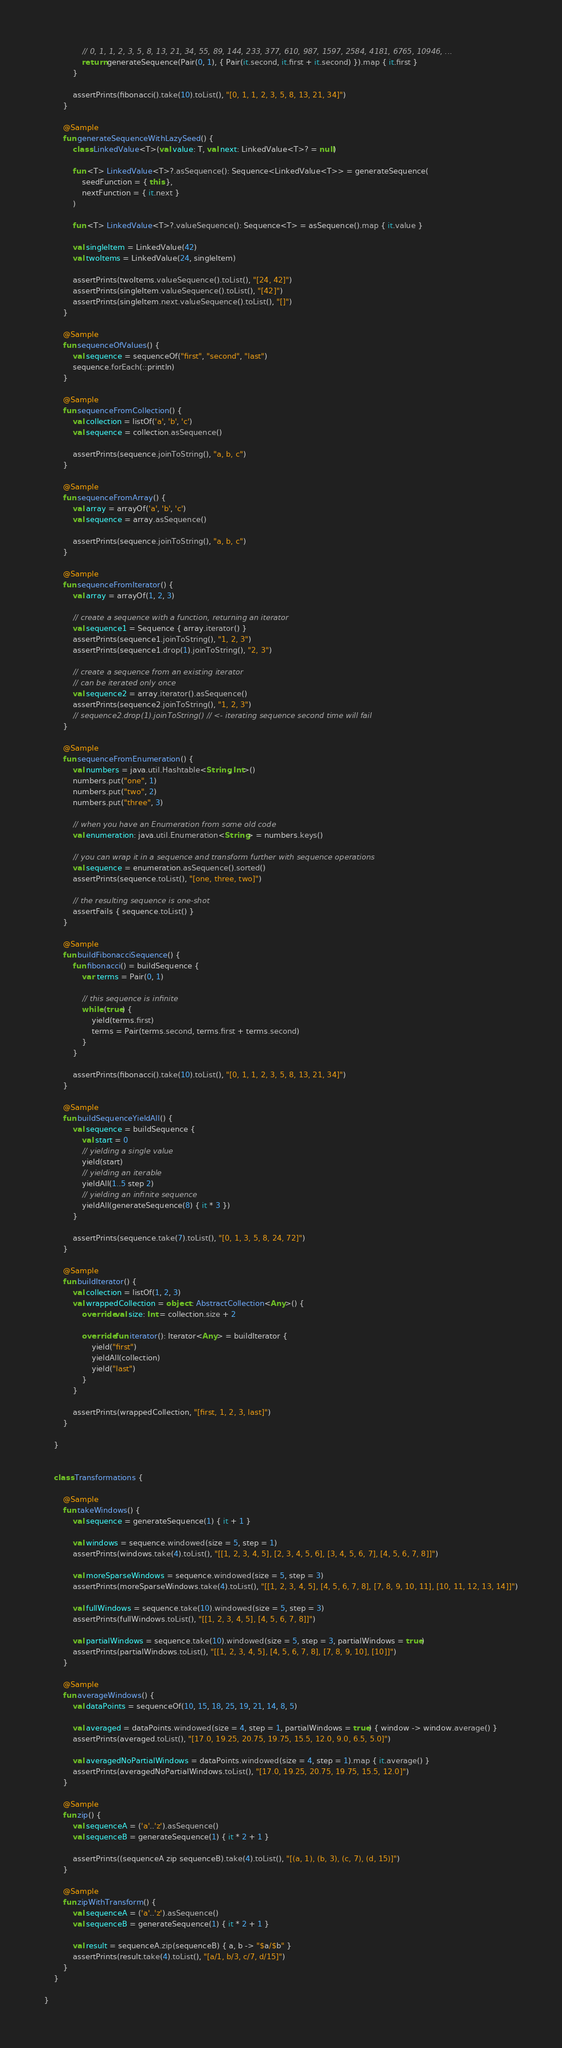<code> <loc_0><loc_0><loc_500><loc_500><_Kotlin_>                // 0, 1, 1, 2, 3, 5, 8, 13, 21, 34, 55, 89, 144, 233, 377, 610, 987, 1597, 2584, 4181, 6765, 10946, ...
                return generateSequence(Pair(0, 1), { Pair(it.second, it.first + it.second) }).map { it.first }
            }

            assertPrints(fibonacci().take(10).toList(), "[0, 1, 1, 2, 3, 5, 8, 13, 21, 34]")
        }

        @Sample
        fun generateSequenceWithLazySeed() {
            class LinkedValue<T>(val value: T, val next: LinkedValue<T>? = null)

            fun <T> LinkedValue<T>?.asSequence(): Sequence<LinkedValue<T>> = generateSequence(
                seedFunction = { this },
                nextFunction = { it.next }
            )

            fun <T> LinkedValue<T>?.valueSequence(): Sequence<T> = asSequence().map { it.value }

            val singleItem = LinkedValue(42)
            val twoItems = LinkedValue(24, singleItem)

            assertPrints(twoItems.valueSequence().toList(), "[24, 42]")
            assertPrints(singleItem.valueSequence().toList(), "[42]")
            assertPrints(singleItem.next.valueSequence().toList(), "[]")
        }

        @Sample
        fun sequenceOfValues() {
            val sequence = sequenceOf("first", "second", "last")
            sequence.forEach(::println)
        }

        @Sample
        fun sequenceFromCollection() {
            val collection = listOf('a', 'b', 'c')
            val sequence = collection.asSequence()

            assertPrints(sequence.joinToString(), "a, b, c")
        }

        @Sample
        fun sequenceFromArray() {
            val array = arrayOf('a', 'b', 'c')
            val sequence = array.asSequence()

            assertPrints(sequence.joinToString(), "a, b, c")
        }

        @Sample
        fun sequenceFromIterator() {
            val array = arrayOf(1, 2, 3)

            // create a sequence with a function, returning an iterator
            val sequence1 = Sequence { array.iterator() }
            assertPrints(sequence1.joinToString(), "1, 2, 3")
            assertPrints(sequence1.drop(1).joinToString(), "2, 3")

            // create a sequence from an existing iterator
            // can be iterated only once
            val sequence2 = array.iterator().asSequence()
            assertPrints(sequence2.joinToString(), "1, 2, 3")
            // sequence2.drop(1).joinToString() // <- iterating sequence second time will fail
        }

        @Sample
        fun sequenceFromEnumeration() {
            val numbers = java.util.Hashtable<String, Int>()
            numbers.put("one", 1)
            numbers.put("two", 2)
            numbers.put("three", 3)

            // when you have an Enumeration from some old code
            val enumeration: java.util.Enumeration<String> = numbers.keys()

            // you can wrap it in a sequence and transform further with sequence operations
            val sequence = enumeration.asSequence().sorted()
            assertPrints(sequence.toList(), "[one, three, two]")

            // the resulting sequence is one-shot
            assertFails { sequence.toList() }
        }

        @Sample
        fun buildFibonacciSequence() {
            fun fibonacci() = buildSequence {
                var terms = Pair(0, 1)

                // this sequence is infinite
                while (true) {
                    yield(terms.first)
                    terms = Pair(terms.second, terms.first + terms.second)
                }
            }

            assertPrints(fibonacci().take(10).toList(), "[0, 1, 1, 2, 3, 5, 8, 13, 21, 34]")
        }

        @Sample
        fun buildSequenceYieldAll() {
            val sequence = buildSequence {
                val start = 0
                // yielding a single value
                yield(start)
                // yielding an iterable
                yieldAll(1..5 step 2)
                // yielding an infinite sequence
                yieldAll(generateSequence(8) { it * 3 })
            }

            assertPrints(sequence.take(7).toList(), "[0, 1, 3, 5, 8, 24, 72]")
        }

        @Sample
        fun buildIterator() {
            val collection = listOf(1, 2, 3)
            val wrappedCollection = object : AbstractCollection<Any>() {
                override val size: Int = collection.size + 2

                override fun iterator(): Iterator<Any> = buildIterator {
                    yield("first")
                    yieldAll(collection)
                    yield("last")
                }
            }

            assertPrints(wrappedCollection, "[first, 1, 2, 3, last]")
        }

    }


    class Transformations {

        @Sample
        fun takeWindows() {
            val sequence = generateSequence(1) { it + 1 }

            val windows = sequence.windowed(size = 5, step = 1)
            assertPrints(windows.take(4).toList(), "[[1, 2, 3, 4, 5], [2, 3, 4, 5, 6], [3, 4, 5, 6, 7], [4, 5, 6, 7, 8]]")

            val moreSparseWindows = sequence.windowed(size = 5, step = 3)
            assertPrints(moreSparseWindows.take(4).toList(), "[[1, 2, 3, 4, 5], [4, 5, 6, 7, 8], [7, 8, 9, 10, 11], [10, 11, 12, 13, 14]]")

            val fullWindows = sequence.take(10).windowed(size = 5, step = 3)
            assertPrints(fullWindows.toList(), "[[1, 2, 3, 4, 5], [4, 5, 6, 7, 8]]")

            val partialWindows = sequence.take(10).windowed(size = 5, step = 3, partialWindows = true)
            assertPrints(partialWindows.toList(), "[[1, 2, 3, 4, 5], [4, 5, 6, 7, 8], [7, 8, 9, 10], [10]]")
        }

        @Sample
        fun averageWindows() {
            val dataPoints = sequenceOf(10, 15, 18, 25, 19, 21, 14, 8, 5)

            val averaged = dataPoints.windowed(size = 4, step = 1, partialWindows = true) { window -> window.average() }
            assertPrints(averaged.toList(), "[17.0, 19.25, 20.75, 19.75, 15.5, 12.0, 9.0, 6.5, 5.0]")

            val averagedNoPartialWindows = dataPoints.windowed(size = 4, step = 1).map { it.average() }
            assertPrints(averagedNoPartialWindows.toList(), "[17.0, 19.25, 20.75, 19.75, 15.5, 12.0]")
        }

        @Sample
        fun zip() {
            val sequenceA = ('a'..'z').asSequence()
            val sequenceB = generateSequence(1) { it * 2 + 1 }

            assertPrints((sequenceA zip sequenceB).take(4).toList(), "[(a, 1), (b, 3), (c, 7), (d, 15)]")
        }

        @Sample
        fun zipWithTransform() {
            val sequenceA = ('a'..'z').asSequence()
            val sequenceB = generateSequence(1) { it * 2 + 1 }

            val result = sequenceA.zip(sequenceB) { a, b -> "$a/$b" }
            assertPrints(result.take(4).toList(), "[a/1, b/3, c/7, d/15]")
        }
    }

}</code> 